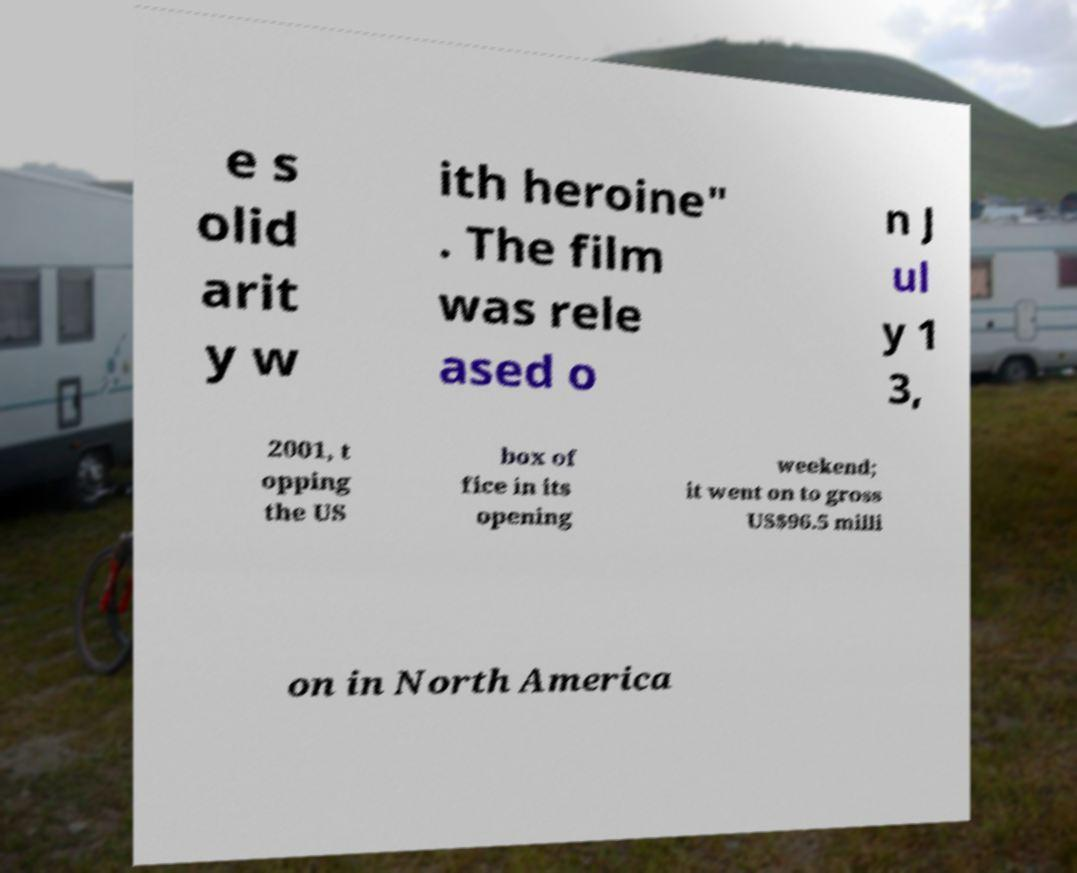Could you assist in decoding the text presented in this image and type it out clearly? e s olid arit y w ith heroine" . The film was rele ased o n J ul y 1 3, 2001, t opping the US box of fice in its opening weekend; it went on to gross US$96.5 milli on in North America 